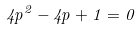<formula> <loc_0><loc_0><loc_500><loc_500>4 p ^ { 2 } - 4 p + 1 = 0</formula> 